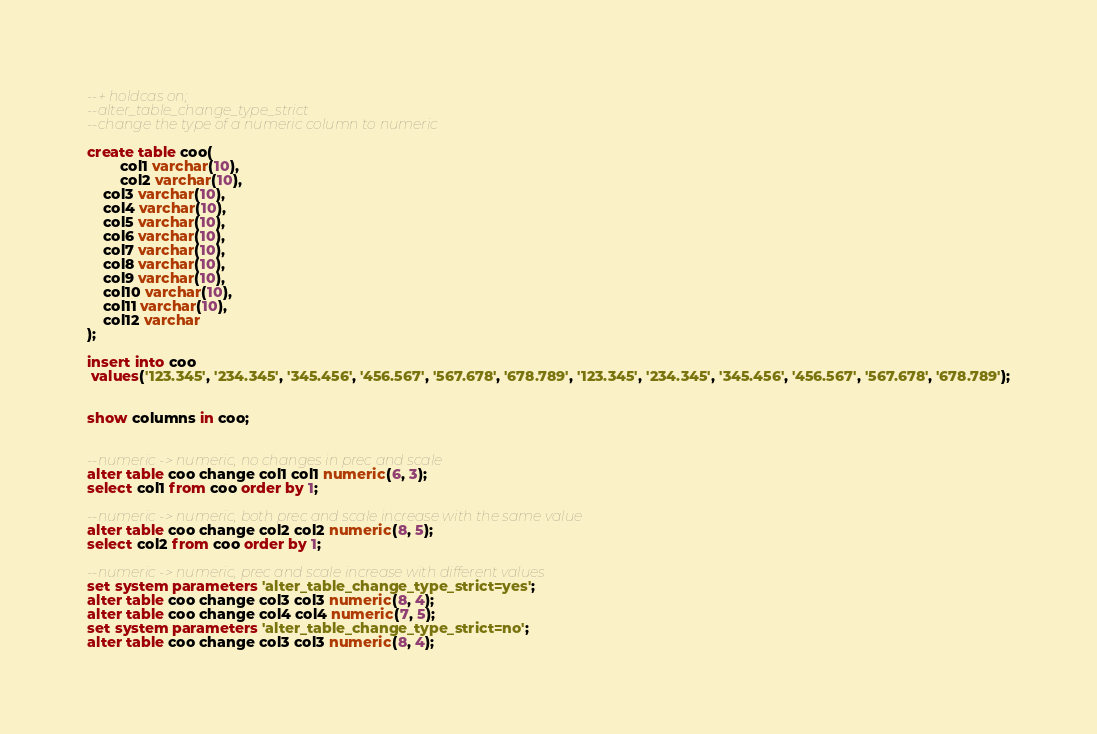<code> <loc_0><loc_0><loc_500><loc_500><_SQL_>--+ holdcas on;
--alter_table_change_type_strict
--change the type of a numeric column to numeric

create table coo(
        col1 varchar(10),
        col2 varchar(10),
	col3 varchar(10),
	col4 varchar(10),
	col5 varchar(10),
	col6 varchar(10),
	col7 varchar(10),
	col8 varchar(10),
	col9 varchar(10),
	col10 varchar(10),
	col11 varchar(10),
	col12 varchar
);

insert into coo
 values('123.345', '234.345', '345.456', '456.567', '567.678', '678.789', '123.345', '234.345', '345.456', '456.567', '567.678', '678.789');


show columns in coo;


--numeric -> numeric, no changes in prec and scale
alter table coo change col1 col1 numeric(6, 3);
select col1 from coo order by 1;

--numeric -> numeric, both prec and scale increase with the same value
alter table coo change col2 col2 numeric(8, 5);
select col2 from coo order by 1;

--numeric -> numeric, prec and scale increase with different values
set system parameters 'alter_table_change_type_strict=yes';
alter table coo change col3 col3 numeric(8, 4);
alter table coo change col4 col4 numeric(7, 5);
set system parameters 'alter_table_change_type_strict=no';
alter table coo change col3 col3 numeric(8, 4);</code> 